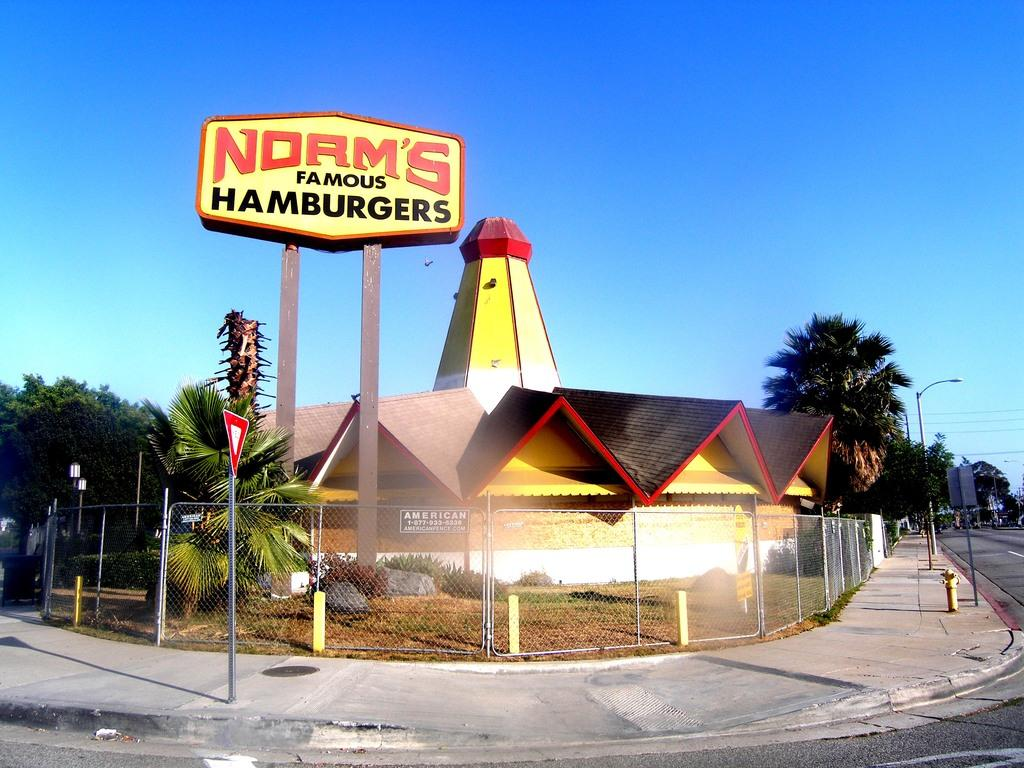What type of path is visible in the image? There is a footpath in the image. What other feature can be seen alongside the footpath? There is a road in the image. What object provides information or directions in the image? There is a signboard in the image. What structures are present in the image that support wires? There are poles in the image. What type of vegetation is visible in the image? There are trees in the image. What type of infrastructure is present in the image that carries wires? There are wires in the image. What type of barrier is visible in the image? There is a fence in the image. What type of building is visible in the image? There is a house in the image. What can be seen in the background of the image? The sky is visible in the background of the image. What type of beast can be seen roaming around the house in the image? There is no beast present in the image; it only features a house, a road, a footpath, a signboard, poles, trees, wires, a fence, and the sky. What type of observation can be made about the behavior of the cream in the image? There is no cream present in the image, so no observation can be made about its behavior. 